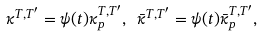Convert formula to latex. <formula><loc_0><loc_0><loc_500><loc_500>\kappa ^ { T , T ^ { \prime } } = \psi ( t ) \kappa _ { p } ^ { T , T ^ { \prime } } , \ \bar { \kappa } ^ { T , T ^ { \prime } } = \psi ( t ) \bar { \kappa } _ { p } ^ { T , T ^ { \prime } } ,</formula> 